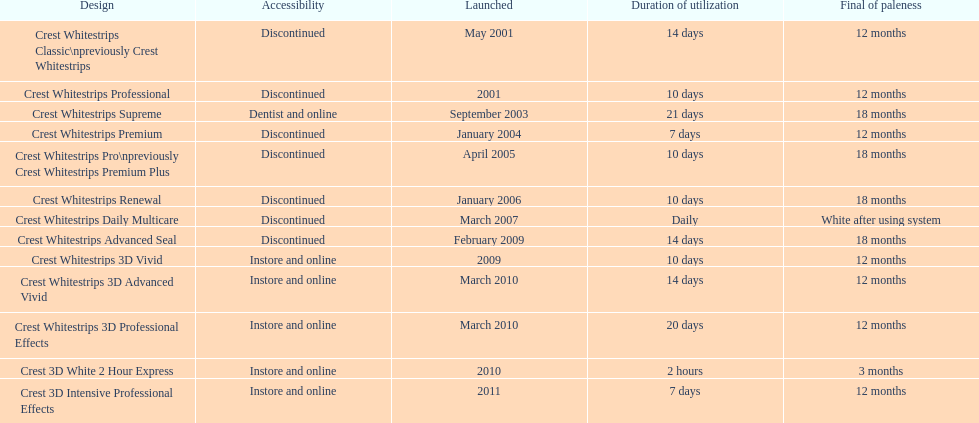Does the crest white strips pro last as long as the crest white strips renewal? Yes. 